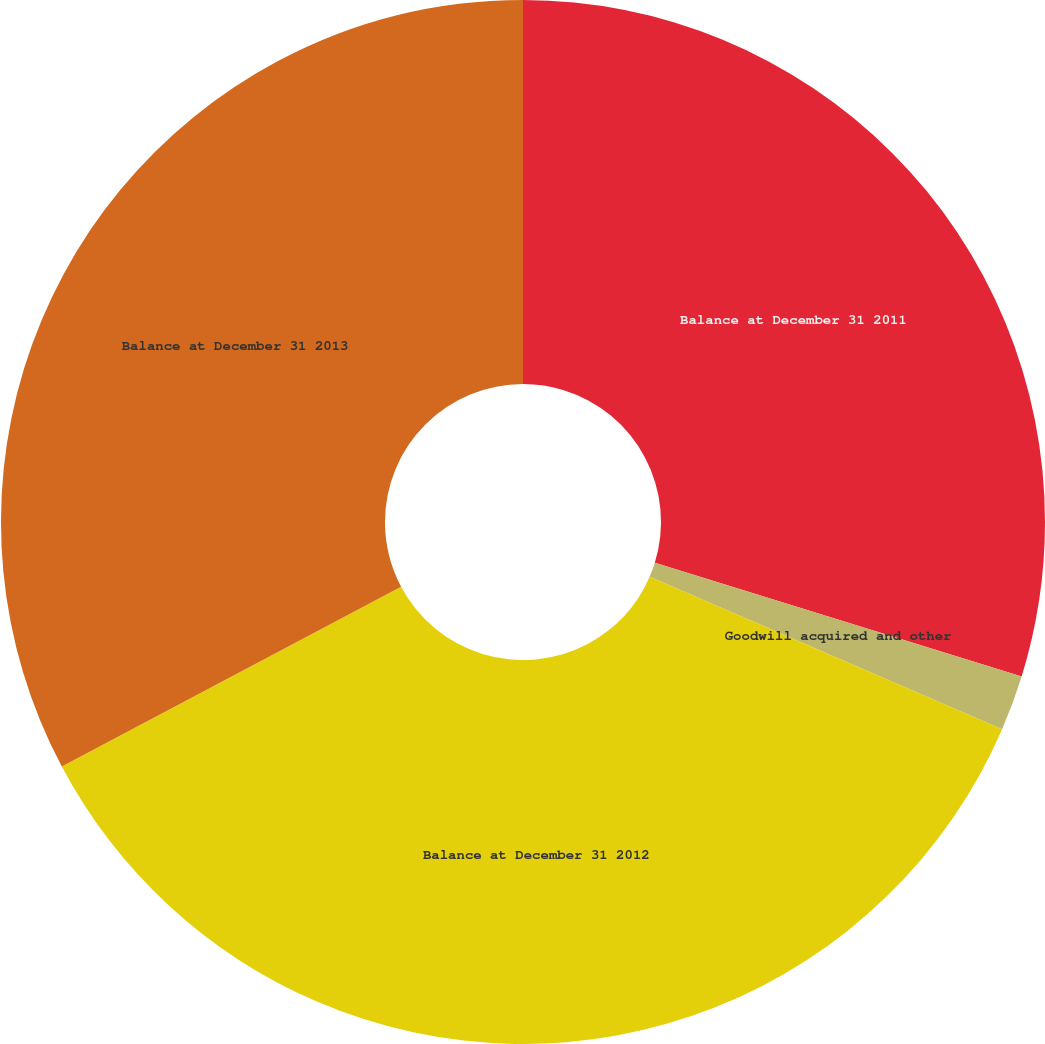<chart> <loc_0><loc_0><loc_500><loc_500><pie_chart><fcel>Balance at December 31 2011<fcel>Goodwill acquired and other<fcel>Balance at December 31 2012<fcel>Balance at December 31 2013<nl><fcel>29.78%<fcel>1.72%<fcel>35.74%<fcel>32.76%<nl></chart> 